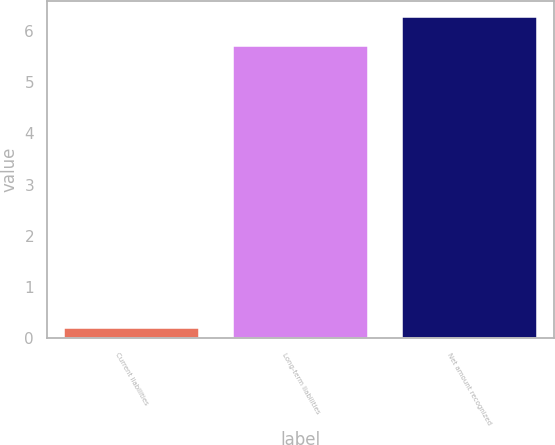Convert chart to OTSL. <chart><loc_0><loc_0><loc_500><loc_500><bar_chart><fcel>Current liabilities<fcel>Long-term liabilities<fcel>Net amount recognized<nl><fcel>0.2<fcel>5.7<fcel>6.27<nl></chart> 